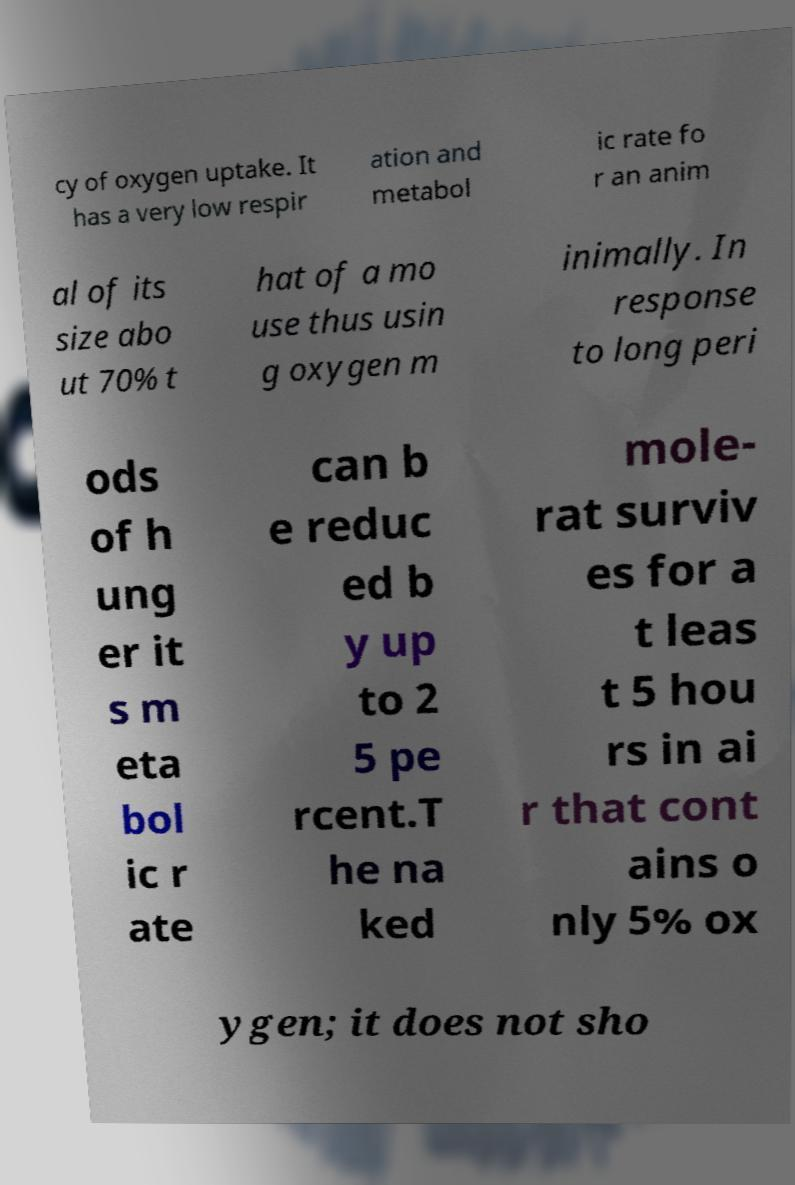There's text embedded in this image that I need extracted. Can you transcribe it verbatim? cy of oxygen uptake. It has a very low respir ation and metabol ic rate fo r an anim al of its size abo ut 70% t hat of a mo use thus usin g oxygen m inimally. In response to long peri ods of h ung er it s m eta bol ic r ate can b e reduc ed b y up to 2 5 pe rcent.T he na ked mole- rat surviv es for a t leas t 5 hou rs in ai r that cont ains o nly 5% ox ygen; it does not sho 